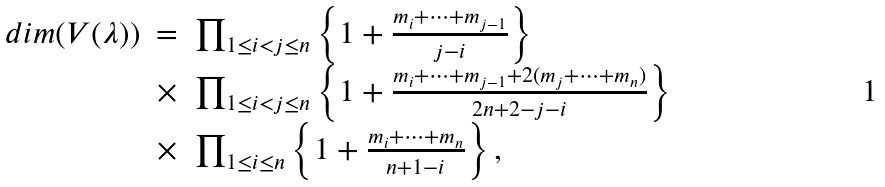<formula> <loc_0><loc_0><loc_500><loc_500>\begin{array} { r c l } d i m ( V ( \lambda ) ) & = & \prod _ { 1 \leq i < j \leq n } \left \{ 1 + \frac { m _ { i } + \cdots + m _ { j - 1 } } { j - i } \right \} \\ & \times & \prod _ { 1 \leq i < j \leq n } \left \{ 1 + \frac { m _ { i } + \cdots + m _ { j - 1 } + 2 ( m _ { j } + \cdots + m _ { n } ) } { 2 n + 2 - j - i } \right \} \\ & \times & \prod _ { 1 \leq i \leq n } \left \{ 1 + \frac { m _ { i } + \cdots + m _ { n } } { n + 1 - i } \right \} , \end{array}</formula> 